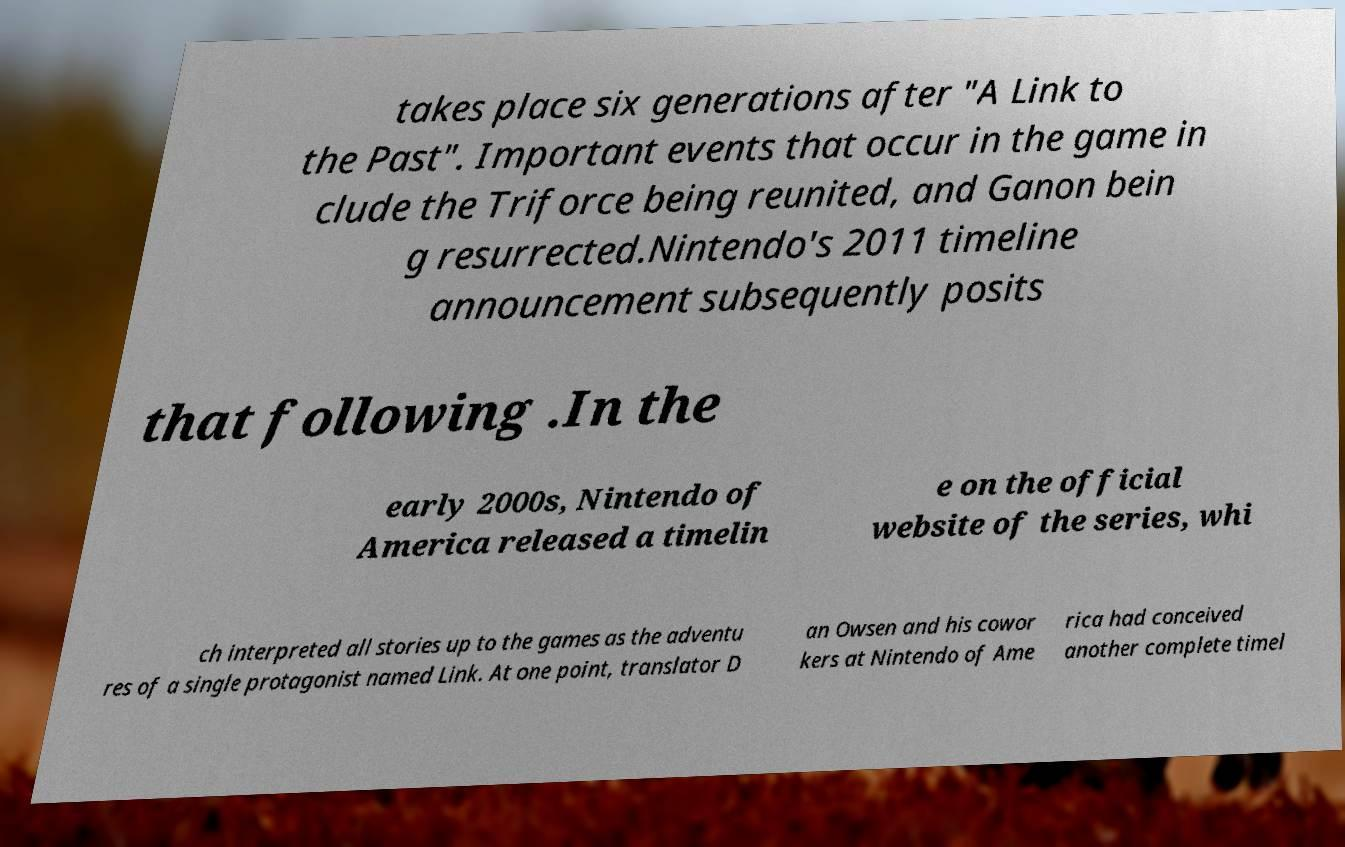Can you accurately transcribe the text from the provided image for me? takes place six generations after "A Link to the Past". Important events that occur in the game in clude the Triforce being reunited, and Ganon bein g resurrected.Nintendo's 2011 timeline announcement subsequently posits that following .In the early 2000s, Nintendo of America released a timelin e on the official website of the series, whi ch interpreted all stories up to the games as the adventu res of a single protagonist named Link. At one point, translator D an Owsen and his cowor kers at Nintendo of Ame rica had conceived another complete timel 